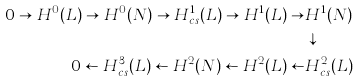<formula> <loc_0><loc_0><loc_500><loc_500>0 \to H ^ { 0 } ( L ) \to H ^ { 0 } ( N ) \to H ^ { 1 } _ { c s } ( L ) \to H ^ { 1 } ( L ) \to & H ^ { 1 } ( N ) \\ & \downarrow \\ 0 \leftarrow H ^ { 3 } _ { c s } ( L ) \leftarrow H ^ { 2 } ( N ) \leftarrow H ^ { 2 } ( L ) \leftarrow & H ^ { 2 } _ { c s } ( L )</formula> 